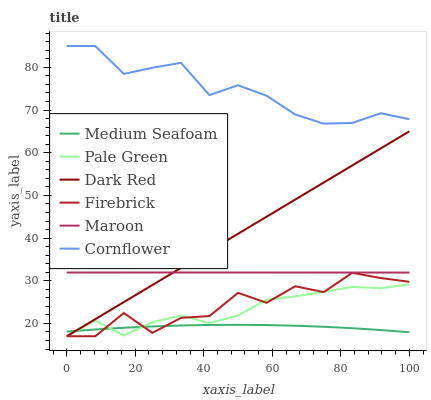Does Medium Seafoam have the minimum area under the curve?
Answer yes or no. Yes. Does Cornflower have the maximum area under the curve?
Answer yes or no. Yes. Does Dark Red have the minimum area under the curve?
Answer yes or no. No. Does Dark Red have the maximum area under the curve?
Answer yes or no. No. Is Dark Red the smoothest?
Answer yes or no. Yes. Is Firebrick the roughest?
Answer yes or no. Yes. Is Firebrick the smoothest?
Answer yes or no. No. Is Dark Red the roughest?
Answer yes or no. No. Does Maroon have the lowest value?
Answer yes or no. No. Does Cornflower have the highest value?
Answer yes or no. Yes. Does Dark Red have the highest value?
Answer yes or no. No. Is Maroon less than Cornflower?
Answer yes or no. Yes. Is Maroon greater than Pale Green?
Answer yes or no. Yes. Does Maroon intersect Cornflower?
Answer yes or no. No. 